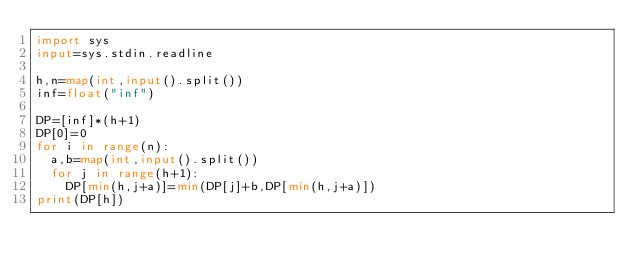<code> <loc_0><loc_0><loc_500><loc_500><_Python_>import sys
input=sys.stdin.readline

h,n=map(int,input().split())
inf=float("inf")

DP=[inf]*(h+1)
DP[0]=0
for i in range(n):
  a,b=map(int,input().split())
  for j in range(h+1):
    DP[min(h,j+a)]=min(DP[j]+b,DP[min(h,j+a)])
print(DP[h])
</code> 